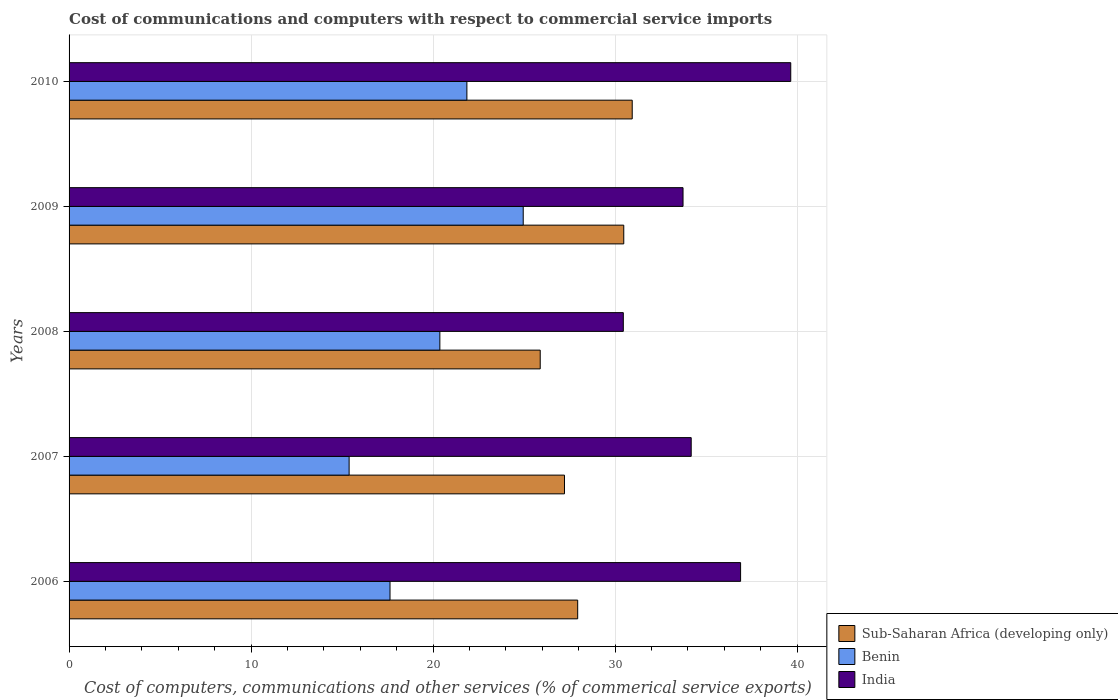How many different coloured bars are there?
Provide a succinct answer. 3. Are the number of bars per tick equal to the number of legend labels?
Your response must be concise. Yes. Are the number of bars on each tick of the Y-axis equal?
Keep it short and to the point. Yes. How many bars are there on the 3rd tick from the bottom?
Your answer should be compact. 3. What is the cost of communications and computers in Sub-Saharan Africa (developing only) in 2009?
Keep it short and to the point. 30.48. Across all years, what is the maximum cost of communications and computers in Sub-Saharan Africa (developing only)?
Give a very brief answer. 30.94. Across all years, what is the minimum cost of communications and computers in Sub-Saharan Africa (developing only)?
Your answer should be compact. 25.89. In which year was the cost of communications and computers in India maximum?
Your response must be concise. 2010. In which year was the cost of communications and computers in Benin minimum?
Ensure brevity in your answer.  2007. What is the total cost of communications and computers in Sub-Saharan Africa (developing only) in the graph?
Ensure brevity in your answer.  142.47. What is the difference between the cost of communications and computers in Benin in 2007 and that in 2010?
Provide a short and direct response. -6.47. What is the difference between the cost of communications and computers in India in 2006 and the cost of communications and computers in Sub-Saharan Africa (developing only) in 2008?
Your answer should be very brief. 11.01. What is the average cost of communications and computers in Sub-Saharan Africa (developing only) per year?
Your response must be concise. 28.49. In the year 2007, what is the difference between the cost of communications and computers in India and cost of communications and computers in Benin?
Your answer should be compact. 18.8. What is the ratio of the cost of communications and computers in Sub-Saharan Africa (developing only) in 2007 to that in 2008?
Ensure brevity in your answer.  1.05. Is the difference between the cost of communications and computers in India in 2007 and 2009 greater than the difference between the cost of communications and computers in Benin in 2007 and 2009?
Your answer should be compact. Yes. What is the difference between the highest and the second highest cost of communications and computers in Benin?
Keep it short and to the point. 3.09. What is the difference between the highest and the lowest cost of communications and computers in India?
Your answer should be very brief. 9.2. What does the 2nd bar from the top in 2006 represents?
Ensure brevity in your answer.  Benin. What does the 1st bar from the bottom in 2006 represents?
Your answer should be very brief. Sub-Saharan Africa (developing only). How many bars are there?
Offer a terse response. 15. Are all the bars in the graph horizontal?
Your response must be concise. Yes. Are the values on the major ticks of X-axis written in scientific E-notation?
Your response must be concise. No. Does the graph contain any zero values?
Make the answer very short. No. Does the graph contain grids?
Provide a short and direct response. Yes. Where does the legend appear in the graph?
Keep it short and to the point. Bottom right. How are the legend labels stacked?
Offer a very short reply. Vertical. What is the title of the graph?
Ensure brevity in your answer.  Cost of communications and computers with respect to commercial service imports. What is the label or title of the X-axis?
Offer a very short reply. Cost of computers, communications and other services (% of commerical service exports). What is the label or title of the Y-axis?
Your response must be concise. Years. What is the Cost of computers, communications and other services (% of commerical service exports) in Sub-Saharan Africa (developing only) in 2006?
Keep it short and to the point. 27.95. What is the Cost of computers, communications and other services (% of commerical service exports) in Benin in 2006?
Keep it short and to the point. 17.63. What is the Cost of computers, communications and other services (% of commerical service exports) of India in 2006?
Your answer should be compact. 36.9. What is the Cost of computers, communications and other services (% of commerical service exports) of Sub-Saharan Africa (developing only) in 2007?
Your answer should be very brief. 27.22. What is the Cost of computers, communications and other services (% of commerical service exports) of Benin in 2007?
Give a very brief answer. 15.39. What is the Cost of computers, communications and other services (% of commerical service exports) in India in 2007?
Offer a very short reply. 34.18. What is the Cost of computers, communications and other services (% of commerical service exports) in Sub-Saharan Africa (developing only) in 2008?
Offer a very short reply. 25.89. What is the Cost of computers, communications and other services (% of commerical service exports) in Benin in 2008?
Your answer should be compact. 20.37. What is the Cost of computers, communications and other services (% of commerical service exports) in India in 2008?
Offer a very short reply. 30.45. What is the Cost of computers, communications and other services (% of commerical service exports) of Sub-Saharan Africa (developing only) in 2009?
Your response must be concise. 30.48. What is the Cost of computers, communications and other services (% of commerical service exports) of Benin in 2009?
Your answer should be very brief. 24.95. What is the Cost of computers, communications and other services (% of commerical service exports) of India in 2009?
Provide a succinct answer. 33.73. What is the Cost of computers, communications and other services (% of commerical service exports) in Sub-Saharan Africa (developing only) in 2010?
Make the answer very short. 30.94. What is the Cost of computers, communications and other services (% of commerical service exports) in Benin in 2010?
Offer a terse response. 21.86. What is the Cost of computers, communications and other services (% of commerical service exports) of India in 2010?
Provide a short and direct response. 39.65. Across all years, what is the maximum Cost of computers, communications and other services (% of commerical service exports) in Sub-Saharan Africa (developing only)?
Give a very brief answer. 30.94. Across all years, what is the maximum Cost of computers, communications and other services (% of commerical service exports) of Benin?
Give a very brief answer. 24.95. Across all years, what is the maximum Cost of computers, communications and other services (% of commerical service exports) in India?
Offer a terse response. 39.65. Across all years, what is the minimum Cost of computers, communications and other services (% of commerical service exports) in Sub-Saharan Africa (developing only)?
Provide a succinct answer. 25.89. Across all years, what is the minimum Cost of computers, communications and other services (% of commerical service exports) of Benin?
Provide a short and direct response. 15.39. Across all years, what is the minimum Cost of computers, communications and other services (% of commerical service exports) in India?
Provide a short and direct response. 30.45. What is the total Cost of computers, communications and other services (% of commerical service exports) in Sub-Saharan Africa (developing only) in the graph?
Keep it short and to the point. 142.47. What is the total Cost of computers, communications and other services (% of commerical service exports) of Benin in the graph?
Offer a very short reply. 100.21. What is the total Cost of computers, communications and other services (% of commerical service exports) in India in the graph?
Provide a short and direct response. 174.92. What is the difference between the Cost of computers, communications and other services (% of commerical service exports) in Sub-Saharan Africa (developing only) in 2006 and that in 2007?
Your answer should be very brief. 0.73. What is the difference between the Cost of computers, communications and other services (% of commerical service exports) of Benin in 2006 and that in 2007?
Give a very brief answer. 2.25. What is the difference between the Cost of computers, communications and other services (% of commerical service exports) of India in 2006 and that in 2007?
Offer a very short reply. 2.71. What is the difference between the Cost of computers, communications and other services (% of commerical service exports) of Sub-Saharan Africa (developing only) in 2006 and that in 2008?
Your answer should be compact. 2.06. What is the difference between the Cost of computers, communications and other services (% of commerical service exports) of Benin in 2006 and that in 2008?
Offer a terse response. -2.74. What is the difference between the Cost of computers, communications and other services (% of commerical service exports) of India in 2006 and that in 2008?
Make the answer very short. 6.44. What is the difference between the Cost of computers, communications and other services (% of commerical service exports) of Sub-Saharan Africa (developing only) in 2006 and that in 2009?
Your answer should be very brief. -2.53. What is the difference between the Cost of computers, communications and other services (% of commerical service exports) of Benin in 2006 and that in 2009?
Your answer should be very brief. -7.32. What is the difference between the Cost of computers, communications and other services (% of commerical service exports) of India in 2006 and that in 2009?
Make the answer very short. 3.16. What is the difference between the Cost of computers, communications and other services (% of commerical service exports) in Sub-Saharan Africa (developing only) in 2006 and that in 2010?
Provide a succinct answer. -3. What is the difference between the Cost of computers, communications and other services (% of commerical service exports) in Benin in 2006 and that in 2010?
Offer a terse response. -4.22. What is the difference between the Cost of computers, communications and other services (% of commerical service exports) of India in 2006 and that in 2010?
Your answer should be very brief. -2.76. What is the difference between the Cost of computers, communications and other services (% of commerical service exports) of Sub-Saharan Africa (developing only) in 2007 and that in 2008?
Offer a very short reply. 1.33. What is the difference between the Cost of computers, communications and other services (% of commerical service exports) in Benin in 2007 and that in 2008?
Make the answer very short. -4.99. What is the difference between the Cost of computers, communications and other services (% of commerical service exports) of India in 2007 and that in 2008?
Make the answer very short. 3.73. What is the difference between the Cost of computers, communications and other services (% of commerical service exports) in Sub-Saharan Africa (developing only) in 2007 and that in 2009?
Provide a short and direct response. -3.26. What is the difference between the Cost of computers, communications and other services (% of commerical service exports) of Benin in 2007 and that in 2009?
Provide a succinct answer. -9.57. What is the difference between the Cost of computers, communications and other services (% of commerical service exports) of India in 2007 and that in 2009?
Your response must be concise. 0.45. What is the difference between the Cost of computers, communications and other services (% of commerical service exports) of Sub-Saharan Africa (developing only) in 2007 and that in 2010?
Offer a terse response. -3.72. What is the difference between the Cost of computers, communications and other services (% of commerical service exports) of Benin in 2007 and that in 2010?
Keep it short and to the point. -6.47. What is the difference between the Cost of computers, communications and other services (% of commerical service exports) of India in 2007 and that in 2010?
Your response must be concise. -5.47. What is the difference between the Cost of computers, communications and other services (% of commerical service exports) in Sub-Saharan Africa (developing only) in 2008 and that in 2009?
Offer a terse response. -4.59. What is the difference between the Cost of computers, communications and other services (% of commerical service exports) of Benin in 2008 and that in 2009?
Keep it short and to the point. -4.58. What is the difference between the Cost of computers, communications and other services (% of commerical service exports) of India in 2008 and that in 2009?
Your answer should be very brief. -3.28. What is the difference between the Cost of computers, communications and other services (% of commerical service exports) in Sub-Saharan Africa (developing only) in 2008 and that in 2010?
Make the answer very short. -5.05. What is the difference between the Cost of computers, communications and other services (% of commerical service exports) in Benin in 2008 and that in 2010?
Provide a short and direct response. -1.49. What is the difference between the Cost of computers, communications and other services (% of commerical service exports) in India in 2008 and that in 2010?
Provide a short and direct response. -9.2. What is the difference between the Cost of computers, communications and other services (% of commerical service exports) in Sub-Saharan Africa (developing only) in 2009 and that in 2010?
Provide a short and direct response. -0.46. What is the difference between the Cost of computers, communications and other services (% of commerical service exports) in Benin in 2009 and that in 2010?
Keep it short and to the point. 3.09. What is the difference between the Cost of computers, communications and other services (% of commerical service exports) of India in 2009 and that in 2010?
Give a very brief answer. -5.92. What is the difference between the Cost of computers, communications and other services (% of commerical service exports) in Sub-Saharan Africa (developing only) in 2006 and the Cost of computers, communications and other services (% of commerical service exports) in Benin in 2007?
Keep it short and to the point. 12.56. What is the difference between the Cost of computers, communications and other services (% of commerical service exports) of Sub-Saharan Africa (developing only) in 2006 and the Cost of computers, communications and other services (% of commerical service exports) of India in 2007?
Provide a succinct answer. -6.24. What is the difference between the Cost of computers, communications and other services (% of commerical service exports) of Benin in 2006 and the Cost of computers, communications and other services (% of commerical service exports) of India in 2007?
Offer a terse response. -16.55. What is the difference between the Cost of computers, communications and other services (% of commerical service exports) of Sub-Saharan Africa (developing only) in 2006 and the Cost of computers, communications and other services (% of commerical service exports) of Benin in 2008?
Make the answer very short. 7.57. What is the difference between the Cost of computers, communications and other services (% of commerical service exports) in Sub-Saharan Africa (developing only) in 2006 and the Cost of computers, communications and other services (% of commerical service exports) in India in 2008?
Ensure brevity in your answer.  -2.51. What is the difference between the Cost of computers, communications and other services (% of commerical service exports) in Benin in 2006 and the Cost of computers, communications and other services (% of commerical service exports) in India in 2008?
Offer a terse response. -12.82. What is the difference between the Cost of computers, communications and other services (% of commerical service exports) in Sub-Saharan Africa (developing only) in 2006 and the Cost of computers, communications and other services (% of commerical service exports) in Benin in 2009?
Offer a very short reply. 2.99. What is the difference between the Cost of computers, communications and other services (% of commerical service exports) in Sub-Saharan Africa (developing only) in 2006 and the Cost of computers, communications and other services (% of commerical service exports) in India in 2009?
Give a very brief answer. -5.79. What is the difference between the Cost of computers, communications and other services (% of commerical service exports) of Benin in 2006 and the Cost of computers, communications and other services (% of commerical service exports) of India in 2009?
Keep it short and to the point. -16.1. What is the difference between the Cost of computers, communications and other services (% of commerical service exports) of Sub-Saharan Africa (developing only) in 2006 and the Cost of computers, communications and other services (% of commerical service exports) of Benin in 2010?
Provide a short and direct response. 6.09. What is the difference between the Cost of computers, communications and other services (% of commerical service exports) in Sub-Saharan Africa (developing only) in 2006 and the Cost of computers, communications and other services (% of commerical service exports) in India in 2010?
Give a very brief answer. -11.71. What is the difference between the Cost of computers, communications and other services (% of commerical service exports) in Benin in 2006 and the Cost of computers, communications and other services (% of commerical service exports) in India in 2010?
Offer a very short reply. -22.02. What is the difference between the Cost of computers, communications and other services (% of commerical service exports) in Sub-Saharan Africa (developing only) in 2007 and the Cost of computers, communications and other services (% of commerical service exports) in Benin in 2008?
Make the answer very short. 6.85. What is the difference between the Cost of computers, communications and other services (% of commerical service exports) of Sub-Saharan Africa (developing only) in 2007 and the Cost of computers, communications and other services (% of commerical service exports) of India in 2008?
Offer a terse response. -3.23. What is the difference between the Cost of computers, communications and other services (% of commerical service exports) in Benin in 2007 and the Cost of computers, communications and other services (% of commerical service exports) in India in 2008?
Offer a very short reply. -15.07. What is the difference between the Cost of computers, communications and other services (% of commerical service exports) in Sub-Saharan Africa (developing only) in 2007 and the Cost of computers, communications and other services (% of commerical service exports) in Benin in 2009?
Make the answer very short. 2.27. What is the difference between the Cost of computers, communications and other services (% of commerical service exports) of Sub-Saharan Africa (developing only) in 2007 and the Cost of computers, communications and other services (% of commerical service exports) of India in 2009?
Keep it short and to the point. -6.51. What is the difference between the Cost of computers, communications and other services (% of commerical service exports) of Benin in 2007 and the Cost of computers, communications and other services (% of commerical service exports) of India in 2009?
Your answer should be compact. -18.35. What is the difference between the Cost of computers, communications and other services (% of commerical service exports) in Sub-Saharan Africa (developing only) in 2007 and the Cost of computers, communications and other services (% of commerical service exports) in Benin in 2010?
Offer a terse response. 5.36. What is the difference between the Cost of computers, communications and other services (% of commerical service exports) of Sub-Saharan Africa (developing only) in 2007 and the Cost of computers, communications and other services (% of commerical service exports) of India in 2010?
Keep it short and to the point. -12.43. What is the difference between the Cost of computers, communications and other services (% of commerical service exports) of Benin in 2007 and the Cost of computers, communications and other services (% of commerical service exports) of India in 2010?
Your response must be concise. -24.27. What is the difference between the Cost of computers, communications and other services (% of commerical service exports) of Sub-Saharan Africa (developing only) in 2008 and the Cost of computers, communications and other services (% of commerical service exports) of Benin in 2009?
Your answer should be very brief. 0.93. What is the difference between the Cost of computers, communications and other services (% of commerical service exports) in Sub-Saharan Africa (developing only) in 2008 and the Cost of computers, communications and other services (% of commerical service exports) in India in 2009?
Give a very brief answer. -7.85. What is the difference between the Cost of computers, communications and other services (% of commerical service exports) of Benin in 2008 and the Cost of computers, communications and other services (% of commerical service exports) of India in 2009?
Provide a succinct answer. -13.36. What is the difference between the Cost of computers, communications and other services (% of commerical service exports) in Sub-Saharan Africa (developing only) in 2008 and the Cost of computers, communications and other services (% of commerical service exports) in Benin in 2010?
Ensure brevity in your answer.  4.03. What is the difference between the Cost of computers, communications and other services (% of commerical service exports) in Sub-Saharan Africa (developing only) in 2008 and the Cost of computers, communications and other services (% of commerical service exports) in India in 2010?
Give a very brief answer. -13.77. What is the difference between the Cost of computers, communications and other services (% of commerical service exports) of Benin in 2008 and the Cost of computers, communications and other services (% of commerical service exports) of India in 2010?
Your response must be concise. -19.28. What is the difference between the Cost of computers, communications and other services (% of commerical service exports) in Sub-Saharan Africa (developing only) in 2009 and the Cost of computers, communications and other services (% of commerical service exports) in Benin in 2010?
Keep it short and to the point. 8.62. What is the difference between the Cost of computers, communications and other services (% of commerical service exports) of Sub-Saharan Africa (developing only) in 2009 and the Cost of computers, communications and other services (% of commerical service exports) of India in 2010?
Provide a short and direct response. -9.18. What is the difference between the Cost of computers, communications and other services (% of commerical service exports) in Benin in 2009 and the Cost of computers, communications and other services (% of commerical service exports) in India in 2010?
Ensure brevity in your answer.  -14.7. What is the average Cost of computers, communications and other services (% of commerical service exports) of Sub-Saharan Africa (developing only) per year?
Make the answer very short. 28.49. What is the average Cost of computers, communications and other services (% of commerical service exports) in Benin per year?
Provide a short and direct response. 20.04. What is the average Cost of computers, communications and other services (% of commerical service exports) in India per year?
Your answer should be very brief. 34.98. In the year 2006, what is the difference between the Cost of computers, communications and other services (% of commerical service exports) of Sub-Saharan Africa (developing only) and Cost of computers, communications and other services (% of commerical service exports) of Benin?
Your answer should be compact. 10.31. In the year 2006, what is the difference between the Cost of computers, communications and other services (% of commerical service exports) of Sub-Saharan Africa (developing only) and Cost of computers, communications and other services (% of commerical service exports) of India?
Your answer should be compact. -8.95. In the year 2006, what is the difference between the Cost of computers, communications and other services (% of commerical service exports) of Benin and Cost of computers, communications and other services (% of commerical service exports) of India?
Ensure brevity in your answer.  -19.26. In the year 2007, what is the difference between the Cost of computers, communications and other services (% of commerical service exports) of Sub-Saharan Africa (developing only) and Cost of computers, communications and other services (% of commerical service exports) of Benin?
Ensure brevity in your answer.  11.83. In the year 2007, what is the difference between the Cost of computers, communications and other services (% of commerical service exports) in Sub-Saharan Africa (developing only) and Cost of computers, communications and other services (% of commerical service exports) in India?
Make the answer very short. -6.96. In the year 2007, what is the difference between the Cost of computers, communications and other services (% of commerical service exports) in Benin and Cost of computers, communications and other services (% of commerical service exports) in India?
Provide a short and direct response. -18.8. In the year 2008, what is the difference between the Cost of computers, communications and other services (% of commerical service exports) in Sub-Saharan Africa (developing only) and Cost of computers, communications and other services (% of commerical service exports) in Benin?
Ensure brevity in your answer.  5.51. In the year 2008, what is the difference between the Cost of computers, communications and other services (% of commerical service exports) of Sub-Saharan Africa (developing only) and Cost of computers, communications and other services (% of commerical service exports) of India?
Provide a succinct answer. -4.57. In the year 2008, what is the difference between the Cost of computers, communications and other services (% of commerical service exports) in Benin and Cost of computers, communications and other services (% of commerical service exports) in India?
Your answer should be very brief. -10.08. In the year 2009, what is the difference between the Cost of computers, communications and other services (% of commerical service exports) of Sub-Saharan Africa (developing only) and Cost of computers, communications and other services (% of commerical service exports) of Benin?
Ensure brevity in your answer.  5.52. In the year 2009, what is the difference between the Cost of computers, communications and other services (% of commerical service exports) of Sub-Saharan Africa (developing only) and Cost of computers, communications and other services (% of commerical service exports) of India?
Your answer should be compact. -3.26. In the year 2009, what is the difference between the Cost of computers, communications and other services (% of commerical service exports) in Benin and Cost of computers, communications and other services (% of commerical service exports) in India?
Your answer should be compact. -8.78. In the year 2010, what is the difference between the Cost of computers, communications and other services (% of commerical service exports) in Sub-Saharan Africa (developing only) and Cost of computers, communications and other services (% of commerical service exports) in Benin?
Provide a succinct answer. 9.08. In the year 2010, what is the difference between the Cost of computers, communications and other services (% of commerical service exports) of Sub-Saharan Africa (developing only) and Cost of computers, communications and other services (% of commerical service exports) of India?
Your answer should be very brief. -8.71. In the year 2010, what is the difference between the Cost of computers, communications and other services (% of commerical service exports) of Benin and Cost of computers, communications and other services (% of commerical service exports) of India?
Offer a terse response. -17.79. What is the ratio of the Cost of computers, communications and other services (% of commerical service exports) of Sub-Saharan Africa (developing only) in 2006 to that in 2007?
Your answer should be compact. 1.03. What is the ratio of the Cost of computers, communications and other services (% of commerical service exports) of Benin in 2006 to that in 2007?
Your response must be concise. 1.15. What is the ratio of the Cost of computers, communications and other services (% of commerical service exports) of India in 2006 to that in 2007?
Offer a very short reply. 1.08. What is the ratio of the Cost of computers, communications and other services (% of commerical service exports) of Sub-Saharan Africa (developing only) in 2006 to that in 2008?
Provide a succinct answer. 1.08. What is the ratio of the Cost of computers, communications and other services (% of commerical service exports) of Benin in 2006 to that in 2008?
Provide a short and direct response. 0.87. What is the ratio of the Cost of computers, communications and other services (% of commerical service exports) of India in 2006 to that in 2008?
Provide a succinct answer. 1.21. What is the ratio of the Cost of computers, communications and other services (% of commerical service exports) in Sub-Saharan Africa (developing only) in 2006 to that in 2009?
Provide a short and direct response. 0.92. What is the ratio of the Cost of computers, communications and other services (% of commerical service exports) of Benin in 2006 to that in 2009?
Your response must be concise. 0.71. What is the ratio of the Cost of computers, communications and other services (% of commerical service exports) of India in 2006 to that in 2009?
Your response must be concise. 1.09. What is the ratio of the Cost of computers, communications and other services (% of commerical service exports) in Sub-Saharan Africa (developing only) in 2006 to that in 2010?
Your answer should be very brief. 0.9. What is the ratio of the Cost of computers, communications and other services (% of commerical service exports) in Benin in 2006 to that in 2010?
Provide a succinct answer. 0.81. What is the ratio of the Cost of computers, communications and other services (% of commerical service exports) in India in 2006 to that in 2010?
Provide a short and direct response. 0.93. What is the ratio of the Cost of computers, communications and other services (% of commerical service exports) of Sub-Saharan Africa (developing only) in 2007 to that in 2008?
Provide a short and direct response. 1.05. What is the ratio of the Cost of computers, communications and other services (% of commerical service exports) of Benin in 2007 to that in 2008?
Your response must be concise. 0.76. What is the ratio of the Cost of computers, communications and other services (% of commerical service exports) of India in 2007 to that in 2008?
Ensure brevity in your answer.  1.12. What is the ratio of the Cost of computers, communications and other services (% of commerical service exports) of Sub-Saharan Africa (developing only) in 2007 to that in 2009?
Offer a very short reply. 0.89. What is the ratio of the Cost of computers, communications and other services (% of commerical service exports) of Benin in 2007 to that in 2009?
Your answer should be very brief. 0.62. What is the ratio of the Cost of computers, communications and other services (% of commerical service exports) in India in 2007 to that in 2009?
Provide a succinct answer. 1.01. What is the ratio of the Cost of computers, communications and other services (% of commerical service exports) of Sub-Saharan Africa (developing only) in 2007 to that in 2010?
Your answer should be very brief. 0.88. What is the ratio of the Cost of computers, communications and other services (% of commerical service exports) of Benin in 2007 to that in 2010?
Offer a very short reply. 0.7. What is the ratio of the Cost of computers, communications and other services (% of commerical service exports) in India in 2007 to that in 2010?
Your answer should be compact. 0.86. What is the ratio of the Cost of computers, communications and other services (% of commerical service exports) in Sub-Saharan Africa (developing only) in 2008 to that in 2009?
Offer a very short reply. 0.85. What is the ratio of the Cost of computers, communications and other services (% of commerical service exports) in Benin in 2008 to that in 2009?
Your answer should be compact. 0.82. What is the ratio of the Cost of computers, communications and other services (% of commerical service exports) in India in 2008 to that in 2009?
Your answer should be compact. 0.9. What is the ratio of the Cost of computers, communications and other services (% of commerical service exports) in Sub-Saharan Africa (developing only) in 2008 to that in 2010?
Your answer should be very brief. 0.84. What is the ratio of the Cost of computers, communications and other services (% of commerical service exports) in Benin in 2008 to that in 2010?
Provide a succinct answer. 0.93. What is the ratio of the Cost of computers, communications and other services (% of commerical service exports) of India in 2008 to that in 2010?
Offer a terse response. 0.77. What is the ratio of the Cost of computers, communications and other services (% of commerical service exports) of Benin in 2009 to that in 2010?
Your answer should be very brief. 1.14. What is the ratio of the Cost of computers, communications and other services (% of commerical service exports) of India in 2009 to that in 2010?
Keep it short and to the point. 0.85. What is the difference between the highest and the second highest Cost of computers, communications and other services (% of commerical service exports) in Sub-Saharan Africa (developing only)?
Provide a succinct answer. 0.46. What is the difference between the highest and the second highest Cost of computers, communications and other services (% of commerical service exports) of Benin?
Your answer should be compact. 3.09. What is the difference between the highest and the second highest Cost of computers, communications and other services (% of commerical service exports) of India?
Ensure brevity in your answer.  2.76. What is the difference between the highest and the lowest Cost of computers, communications and other services (% of commerical service exports) in Sub-Saharan Africa (developing only)?
Offer a very short reply. 5.05. What is the difference between the highest and the lowest Cost of computers, communications and other services (% of commerical service exports) of Benin?
Your answer should be very brief. 9.57. What is the difference between the highest and the lowest Cost of computers, communications and other services (% of commerical service exports) in India?
Keep it short and to the point. 9.2. 